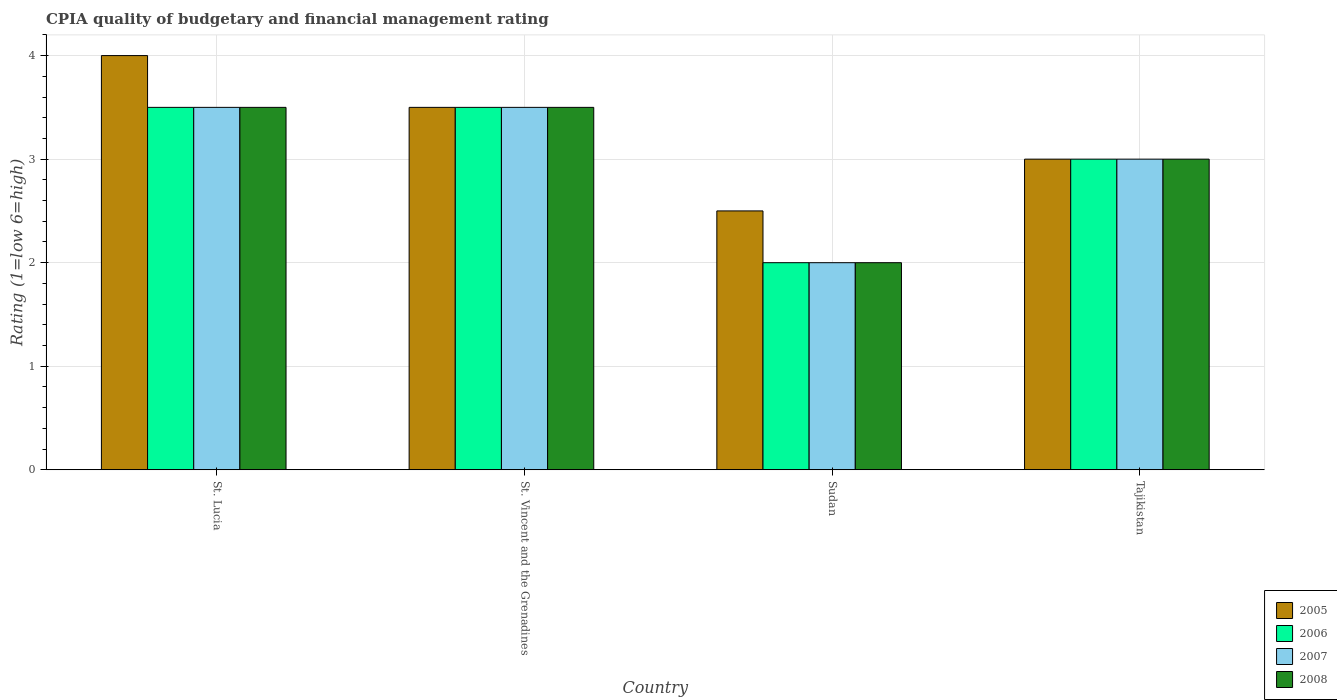How many different coloured bars are there?
Ensure brevity in your answer.  4. How many groups of bars are there?
Make the answer very short. 4. How many bars are there on the 2nd tick from the left?
Provide a short and direct response. 4. How many bars are there on the 3rd tick from the right?
Ensure brevity in your answer.  4. What is the label of the 3rd group of bars from the left?
Ensure brevity in your answer.  Sudan. In how many cases, is the number of bars for a given country not equal to the number of legend labels?
Offer a very short reply. 0. Across all countries, what is the maximum CPIA rating in 2005?
Give a very brief answer. 4. In which country was the CPIA rating in 2005 maximum?
Your answer should be very brief. St. Lucia. In which country was the CPIA rating in 2006 minimum?
Your answer should be compact. Sudan. What is the total CPIA rating in 2008 in the graph?
Make the answer very short. 12. What is the difference between the CPIA rating in 2006 in St. Lucia and that in Sudan?
Your answer should be very brief. 1.5. What is the difference between the CPIA rating of/in 2007 and CPIA rating of/in 2008 in Sudan?
Offer a very short reply. 0. What is the ratio of the CPIA rating in 2005 in St. Vincent and the Grenadines to that in Tajikistan?
Ensure brevity in your answer.  1.17. Is the difference between the CPIA rating in 2007 in St. Lucia and Sudan greater than the difference between the CPIA rating in 2008 in St. Lucia and Sudan?
Your answer should be compact. No. In how many countries, is the CPIA rating in 2005 greater than the average CPIA rating in 2005 taken over all countries?
Offer a terse response. 2. Is the sum of the CPIA rating in 2007 in St. Lucia and Tajikistan greater than the maximum CPIA rating in 2008 across all countries?
Offer a terse response. Yes. What does the 4th bar from the left in St. Vincent and the Grenadines represents?
Provide a short and direct response. 2008. Are all the bars in the graph horizontal?
Make the answer very short. No. What is the difference between two consecutive major ticks on the Y-axis?
Your response must be concise. 1. Does the graph contain any zero values?
Offer a terse response. No. What is the title of the graph?
Give a very brief answer. CPIA quality of budgetary and financial management rating. What is the label or title of the Y-axis?
Provide a short and direct response. Rating (1=low 6=high). What is the Rating (1=low 6=high) in 2006 in St. Lucia?
Provide a succinct answer. 3.5. What is the Rating (1=low 6=high) of 2007 in St. Lucia?
Provide a succinct answer. 3.5. What is the Rating (1=low 6=high) in 2006 in St. Vincent and the Grenadines?
Your answer should be compact. 3.5. What is the Rating (1=low 6=high) of 2007 in St. Vincent and the Grenadines?
Ensure brevity in your answer.  3.5. What is the Rating (1=low 6=high) of 2005 in Sudan?
Offer a very short reply. 2.5. What is the Rating (1=low 6=high) in 2006 in Sudan?
Provide a short and direct response. 2. What is the Rating (1=low 6=high) of 2008 in Sudan?
Your answer should be very brief. 2. What is the Rating (1=low 6=high) of 2006 in Tajikistan?
Provide a short and direct response. 3. What is the Rating (1=low 6=high) in 2008 in Tajikistan?
Ensure brevity in your answer.  3. Across all countries, what is the maximum Rating (1=low 6=high) in 2007?
Offer a terse response. 3.5. Across all countries, what is the minimum Rating (1=low 6=high) in 2005?
Your answer should be very brief. 2.5. Across all countries, what is the minimum Rating (1=low 6=high) in 2006?
Give a very brief answer. 2. Across all countries, what is the minimum Rating (1=low 6=high) in 2008?
Your answer should be very brief. 2. What is the total Rating (1=low 6=high) of 2006 in the graph?
Keep it short and to the point. 12. What is the total Rating (1=low 6=high) in 2007 in the graph?
Your response must be concise. 12. What is the total Rating (1=low 6=high) of 2008 in the graph?
Give a very brief answer. 12. What is the difference between the Rating (1=low 6=high) in 2005 in St. Lucia and that in St. Vincent and the Grenadines?
Give a very brief answer. 0.5. What is the difference between the Rating (1=low 6=high) of 2006 in St. Lucia and that in St. Vincent and the Grenadines?
Make the answer very short. 0. What is the difference between the Rating (1=low 6=high) in 2007 in St. Lucia and that in St. Vincent and the Grenadines?
Keep it short and to the point. 0. What is the difference between the Rating (1=low 6=high) of 2005 in St. Lucia and that in Sudan?
Offer a very short reply. 1.5. What is the difference between the Rating (1=low 6=high) of 2007 in St. Lucia and that in Sudan?
Make the answer very short. 1.5. What is the difference between the Rating (1=low 6=high) of 2005 in St. Vincent and the Grenadines and that in Sudan?
Offer a terse response. 1. What is the difference between the Rating (1=low 6=high) in 2006 in St. Vincent and the Grenadines and that in Sudan?
Your answer should be very brief. 1.5. What is the difference between the Rating (1=low 6=high) of 2005 in St. Vincent and the Grenadines and that in Tajikistan?
Provide a short and direct response. 0.5. What is the difference between the Rating (1=low 6=high) in 2008 in St. Vincent and the Grenadines and that in Tajikistan?
Offer a terse response. 0.5. What is the difference between the Rating (1=low 6=high) in 2005 in Sudan and that in Tajikistan?
Provide a short and direct response. -0.5. What is the difference between the Rating (1=low 6=high) in 2006 in Sudan and that in Tajikistan?
Keep it short and to the point. -1. What is the difference between the Rating (1=low 6=high) in 2007 in Sudan and that in Tajikistan?
Make the answer very short. -1. What is the difference between the Rating (1=low 6=high) in 2008 in Sudan and that in Tajikistan?
Keep it short and to the point. -1. What is the difference between the Rating (1=low 6=high) in 2005 in St. Lucia and the Rating (1=low 6=high) in 2006 in St. Vincent and the Grenadines?
Keep it short and to the point. 0.5. What is the difference between the Rating (1=low 6=high) of 2006 in St. Lucia and the Rating (1=low 6=high) of 2007 in St. Vincent and the Grenadines?
Provide a short and direct response. 0. What is the difference between the Rating (1=low 6=high) of 2006 in St. Lucia and the Rating (1=low 6=high) of 2008 in St. Vincent and the Grenadines?
Offer a very short reply. 0. What is the difference between the Rating (1=low 6=high) in 2005 in St. Lucia and the Rating (1=low 6=high) in 2007 in Sudan?
Provide a short and direct response. 2. What is the difference between the Rating (1=low 6=high) in 2005 in St. Lucia and the Rating (1=low 6=high) in 2008 in Sudan?
Your response must be concise. 2. What is the difference between the Rating (1=low 6=high) of 2007 in St. Lucia and the Rating (1=low 6=high) of 2008 in Sudan?
Provide a succinct answer. 1.5. What is the difference between the Rating (1=low 6=high) in 2005 in St. Lucia and the Rating (1=low 6=high) in 2006 in Tajikistan?
Offer a terse response. 1. What is the difference between the Rating (1=low 6=high) in 2005 in St. Lucia and the Rating (1=low 6=high) in 2007 in Tajikistan?
Provide a short and direct response. 1. What is the difference between the Rating (1=low 6=high) of 2006 in St. Lucia and the Rating (1=low 6=high) of 2007 in Tajikistan?
Your answer should be compact. 0.5. What is the difference between the Rating (1=low 6=high) in 2006 in St. Lucia and the Rating (1=low 6=high) in 2008 in Tajikistan?
Provide a short and direct response. 0.5. What is the difference between the Rating (1=low 6=high) of 2006 in St. Vincent and the Grenadines and the Rating (1=low 6=high) of 2008 in Sudan?
Your answer should be compact. 1.5. What is the difference between the Rating (1=low 6=high) of 2005 in St. Vincent and the Grenadines and the Rating (1=low 6=high) of 2007 in Tajikistan?
Offer a terse response. 0.5. What is the difference between the Rating (1=low 6=high) of 2006 in St. Vincent and the Grenadines and the Rating (1=low 6=high) of 2007 in Tajikistan?
Provide a short and direct response. 0.5. What is the difference between the Rating (1=low 6=high) in 2006 in St. Vincent and the Grenadines and the Rating (1=low 6=high) in 2008 in Tajikistan?
Your response must be concise. 0.5. What is the difference between the Rating (1=low 6=high) of 2007 in St. Vincent and the Grenadines and the Rating (1=low 6=high) of 2008 in Tajikistan?
Make the answer very short. 0.5. What is the difference between the Rating (1=low 6=high) of 2006 in Sudan and the Rating (1=low 6=high) of 2007 in Tajikistan?
Offer a very short reply. -1. What is the difference between the Rating (1=low 6=high) of 2006 in Sudan and the Rating (1=low 6=high) of 2008 in Tajikistan?
Provide a succinct answer. -1. What is the average Rating (1=low 6=high) of 2005 per country?
Your answer should be compact. 3.25. What is the difference between the Rating (1=low 6=high) in 2005 and Rating (1=low 6=high) in 2007 in St. Lucia?
Ensure brevity in your answer.  0.5. What is the difference between the Rating (1=low 6=high) in 2005 and Rating (1=low 6=high) in 2008 in St. Lucia?
Give a very brief answer. 0.5. What is the difference between the Rating (1=low 6=high) of 2006 and Rating (1=low 6=high) of 2007 in St. Lucia?
Your response must be concise. 0. What is the difference between the Rating (1=low 6=high) in 2007 and Rating (1=low 6=high) in 2008 in St. Lucia?
Make the answer very short. 0. What is the difference between the Rating (1=low 6=high) of 2006 and Rating (1=low 6=high) of 2007 in St. Vincent and the Grenadines?
Provide a succinct answer. 0. What is the difference between the Rating (1=low 6=high) of 2007 and Rating (1=low 6=high) of 2008 in St. Vincent and the Grenadines?
Your response must be concise. 0. What is the difference between the Rating (1=low 6=high) of 2005 and Rating (1=low 6=high) of 2006 in Sudan?
Offer a terse response. 0.5. What is the difference between the Rating (1=low 6=high) in 2005 and Rating (1=low 6=high) in 2008 in Sudan?
Keep it short and to the point. 0.5. What is the difference between the Rating (1=low 6=high) in 2006 and Rating (1=low 6=high) in 2008 in Sudan?
Your answer should be compact. 0. What is the difference between the Rating (1=low 6=high) of 2005 and Rating (1=low 6=high) of 2007 in Tajikistan?
Your answer should be very brief. 0. What is the difference between the Rating (1=low 6=high) in 2005 and Rating (1=low 6=high) in 2008 in Tajikistan?
Your response must be concise. 0. What is the difference between the Rating (1=low 6=high) in 2006 and Rating (1=low 6=high) in 2007 in Tajikistan?
Provide a short and direct response. 0. What is the difference between the Rating (1=low 6=high) of 2006 and Rating (1=low 6=high) of 2008 in Tajikistan?
Offer a very short reply. 0. What is the difference between the Rating (1=low 6=high) of 2007 and Rating (1=low 6=high) of 2008 in Tajikistan?
Your answer should be compact. 0. What is the ratio of the Rating (1=low 6=high) in 2005 in St. Lucia to that in St. Vincent and the Grenadines?
Make the answer very short. 1.14. What is the ratio of the Rating (1=low 6=high) in 2006 in St. Lucia to that in St. Vincent and the Grenadines?
Your answer should be compact. 1. What is the ratio of the Rating (1=low 6=high) in 2006 in St. Lucia to that in Sudan?
Your answer should be very brief. 1.75. What is the ratio of the Rating (1=low 6=high) in 2006 in St. Lucia to that in Tajikistan?
Offer a very short reply. 1.17. What is the ratio of the Rating (1=low 6=high) in 2007 in St. Lucia to that in Tajikistan?
Give a very brief answer. 1.17. What is the ratio of the Rating (1=low 6=high) in 2008 in St. Lucia to that in Tajikistan?
Your answer should be very brief. 1.17. What is the ratio of the Rating (1=low 6=high) in 2006 in St. Vincent and the Grenadines to that in Tajikistan?
Give a very brief answer. 1.17. What is the ratio of the Rating (1=low 6=high) in 2007 in St. Vincent and the Grenadines to that in Tajikistan?
Give a very brief answer. 1.17. What is the ratio of the Rating (1=low 6=high) of 2008 in Sudan to that in Tajikistan?
Provide a succinct answer. 0.67. What is the difference between the highest and the lowest Rating (1=low 6=high) of 2005?
Your response must be concise. 1.5. What is the difference between the highest and the lowest Rating (1=low 6=high) in 2006?
Give a very brief answer. 1.5. 